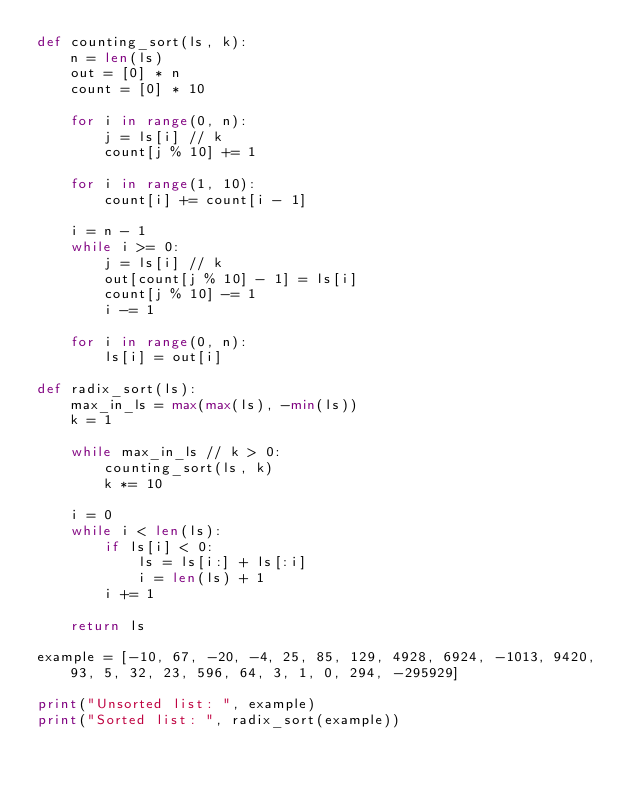Convert code to text. <code><loc_0><loc_0><loc_500><loc_500><_Python_>def counting_sort(ls, k):
	n = len(ls)
	out = [0] * n
	count = [0] * 10

	for i in range(0, n):
		j = ls[i] // k
		count[j % 10] += 1

	for i in range(1, 10):
		count[i] += count[i - 1]

	i = n - 1
	while i >= 0:
		j = ls[i] // k
		out[count[j % 10] - 1] = ls[i]
		count[j % 10] -= 1
		i -= 1

	for i in range(0, n):
		ls[i] = out[i]

def radix_sort(ls):
	max_in_ls = max(max(ls), -min(ls))
	k = 1

	while max_in_ls // k > 0:
		counting_sort(ls, k)
		k *= 10

	i = 0	
	while i < len(ls):
		if ls[i] < 0:
			ls = ls[i:] + ls[:i]
			i = len(ls) + 1
		i += 1

	return ls
			
example = [-10, 67, -20, -4, 25, 85, 129, 4928, 6924, -1013, 9420, 93, 5, 32, 23, 596, 64, 3, 1, 0, 294, -295929]

print("Unsorted list: ", example)
print("Sorted list: ", radix_sort(example))</code> 